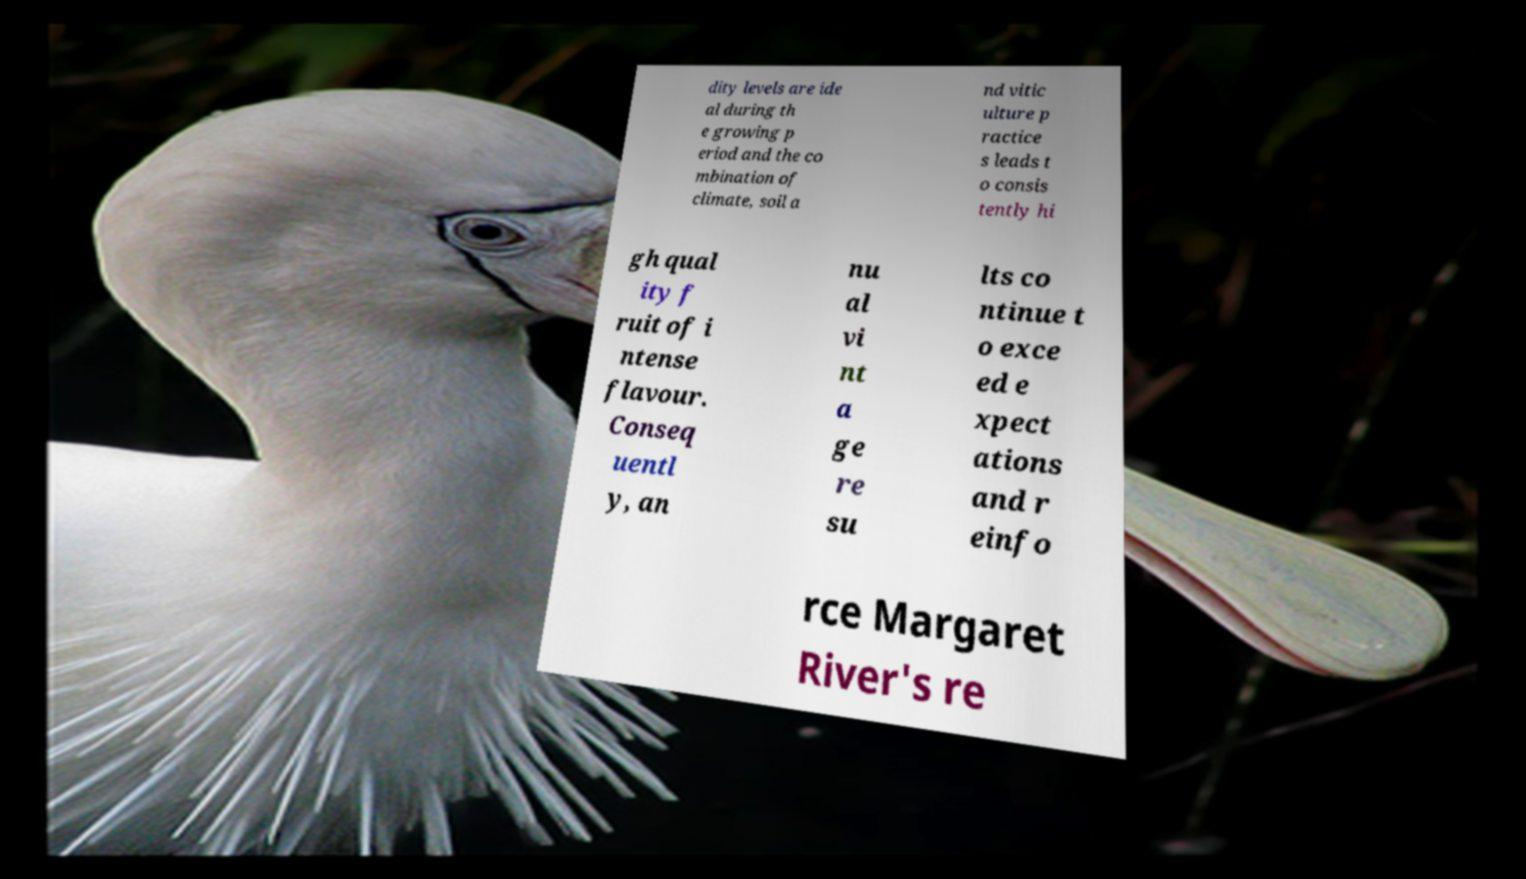Could you assist in decoding the text presented in this image and type it out clearly? dity levels are ide al during th e growing p eriod and the co mbination of climate, soil a nd vitic ulture p ractice s leads t o consis tently hi gh qual ity f ruit of i ntense flavour. Conseq uentl y, an nu al vi nt a ge re su lts co ntinue t o exce ed e xpect ations and r einfo rce Margaret River's re 